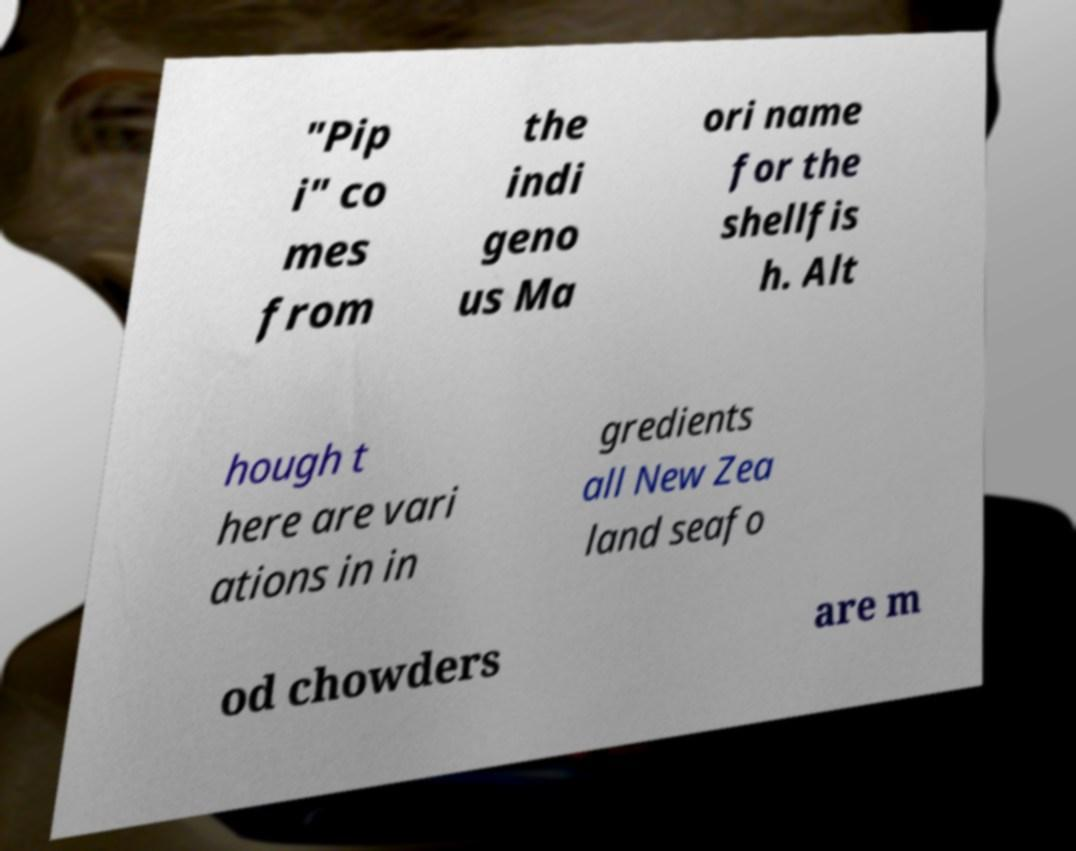Can you read and provide the text displayed in the image?This photo seems to have some interesting text. Can you extract and type it out for me? "Pip i" co mes from the indi geno us Ma ori name for the shellfis h. Alt hough t here are vari ations in in gredients all New Zea land seafo od chowders are m 